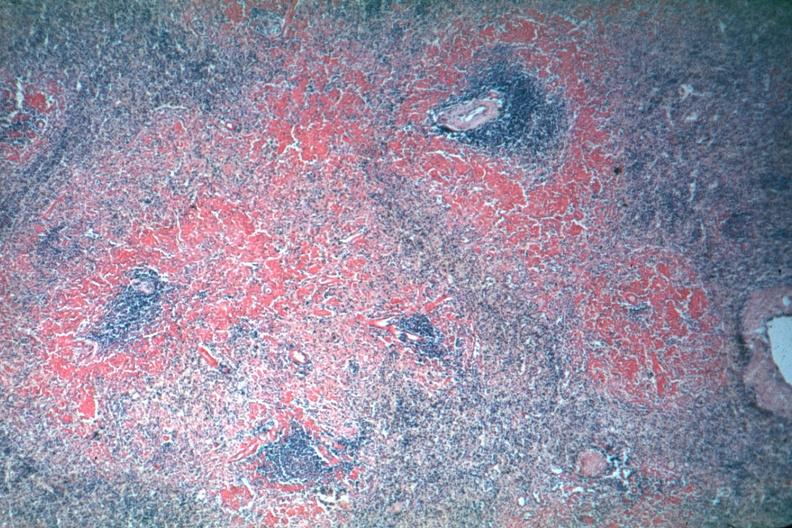s spleen present?
Answer the question using a single word or phrase. Yes 